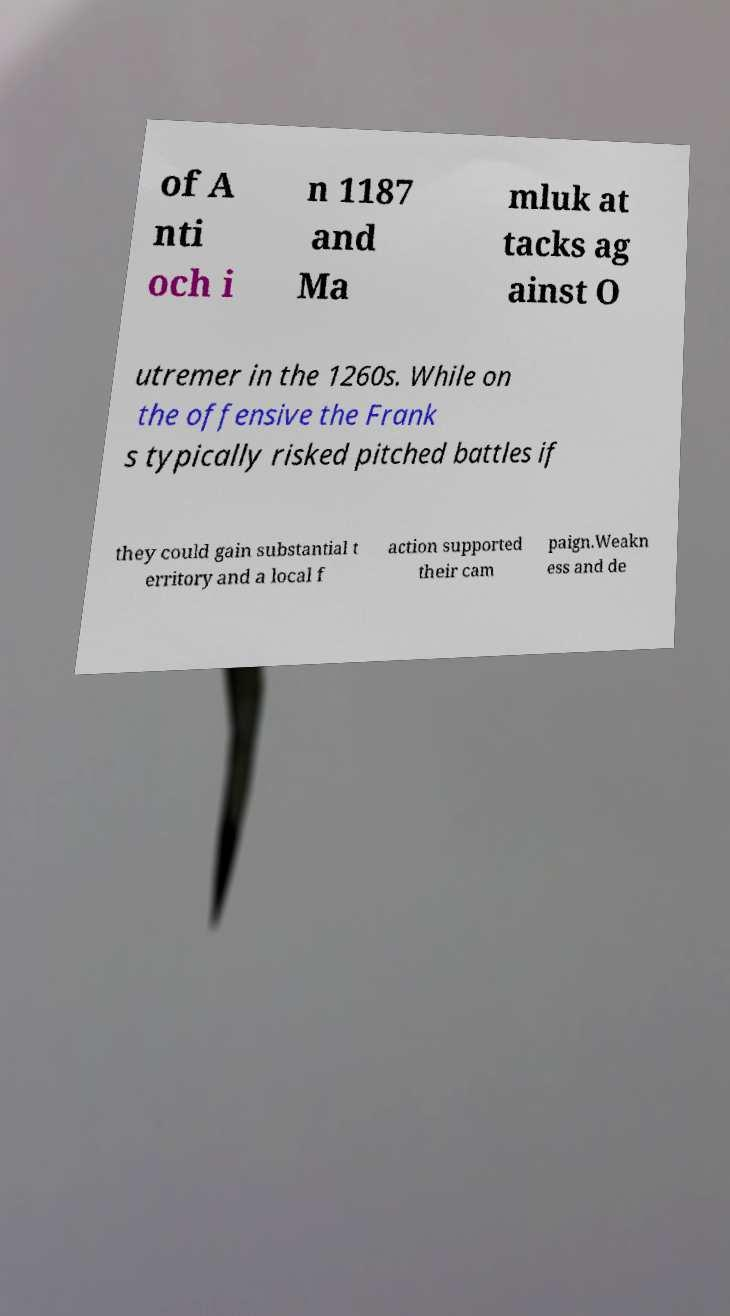Please identify and transcribe the text found in this image. of A nti och i n 1187 and Ma mluk at tacks ag ainst O utremer in the 1260s. While on the offensive the Frank s typically risked pitched battles if they could gain substantial t erritory and a local f action supported their cam paign.Weakn ess and de 